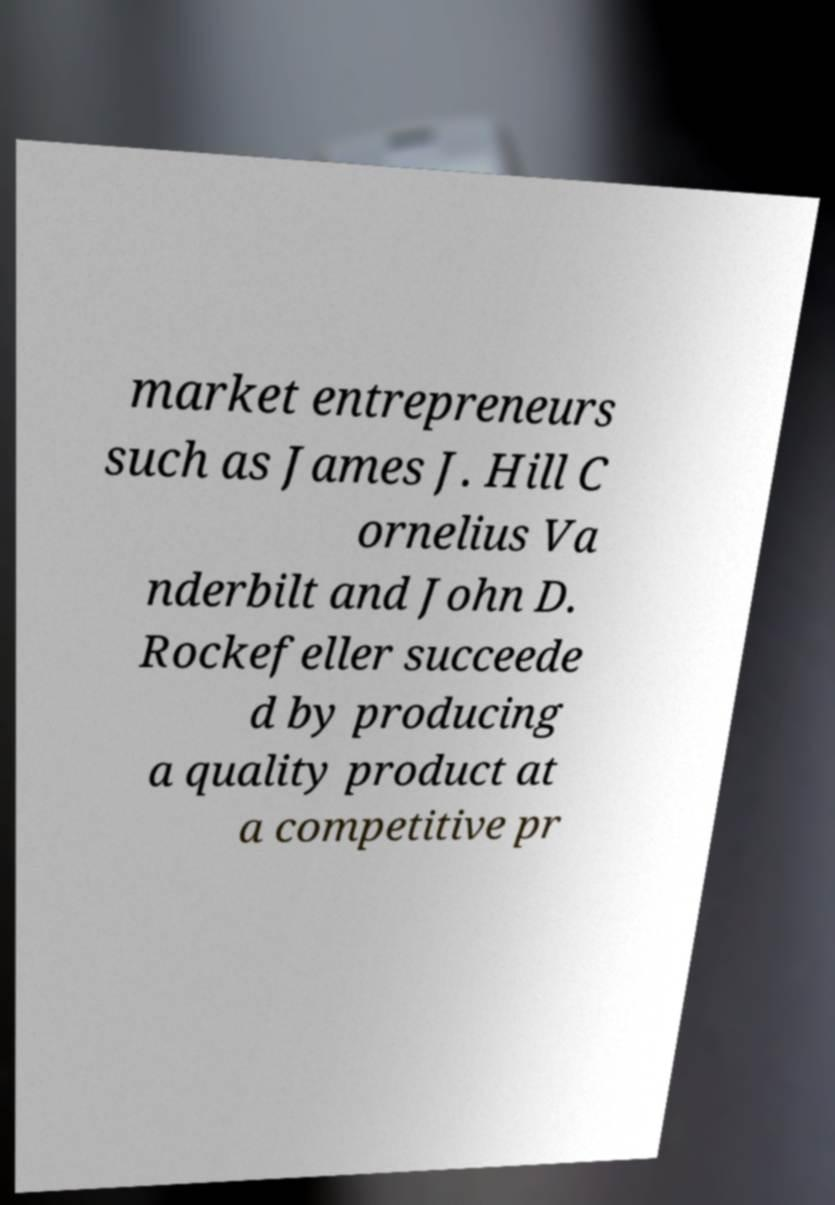Please read and relay the text visible in this image. What does it say? market entrepreneurs such as James J. Hill C ornelius Va nderbilt and John D. Rockefeller succeede d by producing a quality product at a competitive pr 